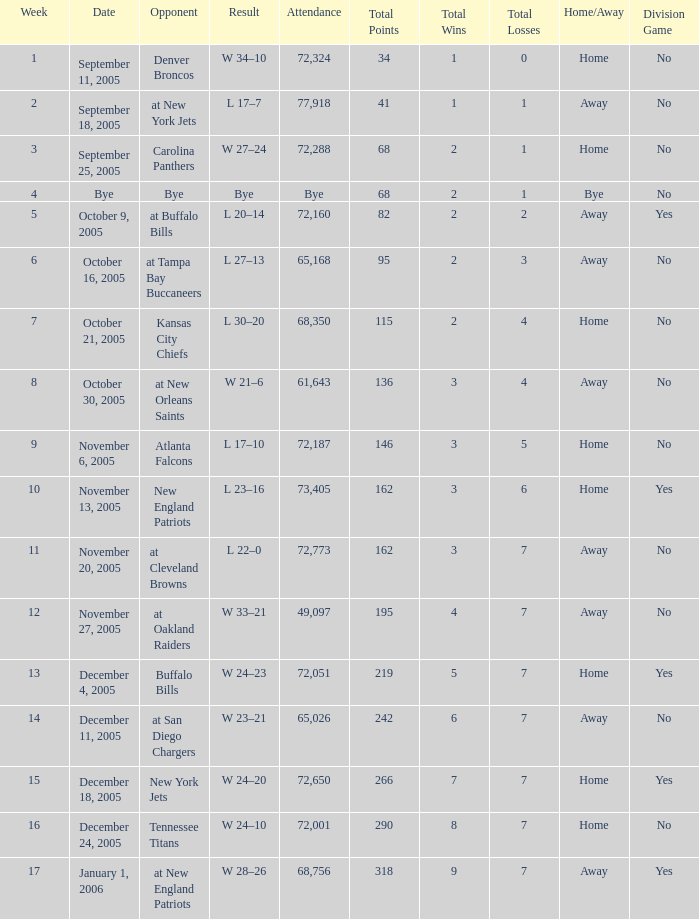What is the Week with a Date of Bye? 1.0. 